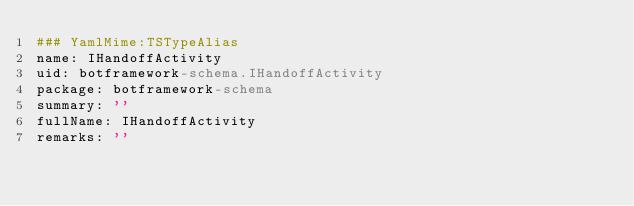Convert code to text. <code><loc_0><loc_0><loc_500><loc_500><_YAML_>### YamlMime:TSTypeAlias
name: IHandoffActivity
uid: botframework-schema.IHandoffActivity
package: botframework-schema
summary: ''
fullName: IHandoffActivity
remarks: ''</code> 